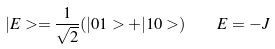<formula> <loc_0><loc_0><loc_500><loc_500>| E > = \frac { 1 } { \sqrt { 2 } } ( | 0 1 > + | 1 0 > ) \quad E = - J</formula> 